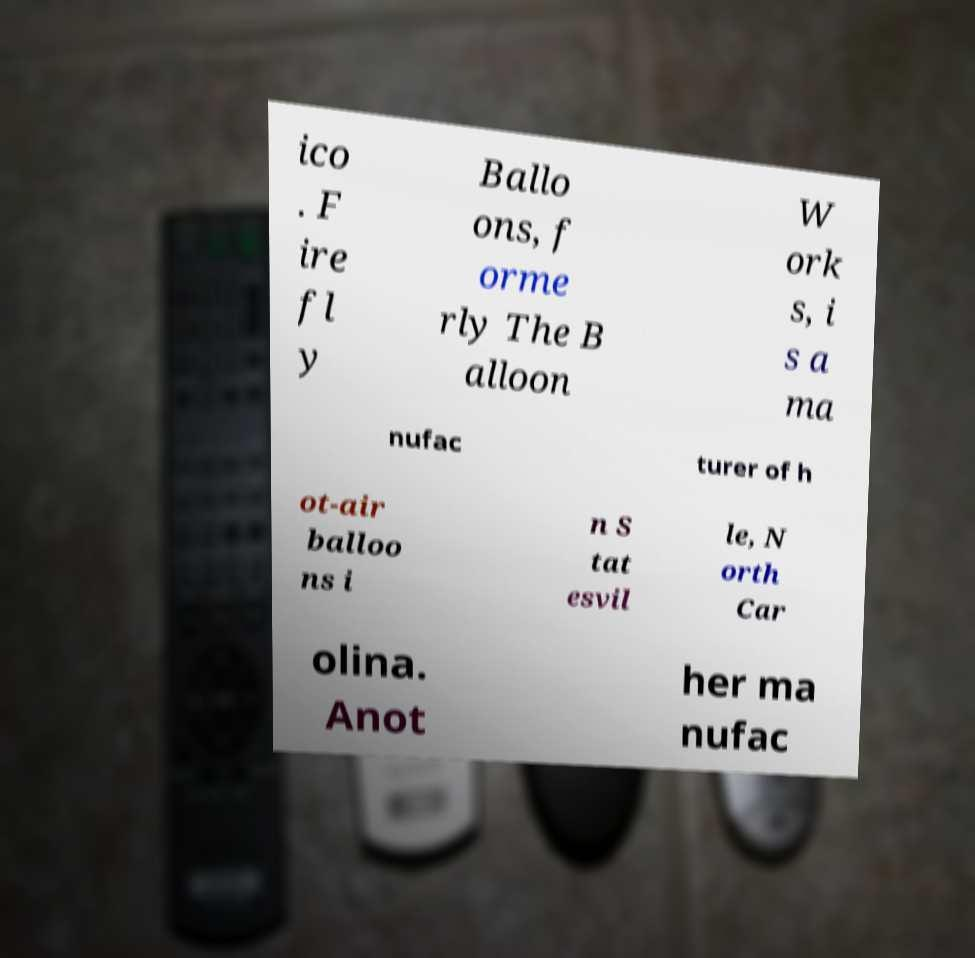Can you accurately transcribe the text from the provided image for me? ico . F ire fl y Ballo ons, f orme rly The B alloon W ork s, i s a ma nufac turer of h ot-air balloo ns i n S tat esvil le, N orth Car olina. Anot her ma nufac 